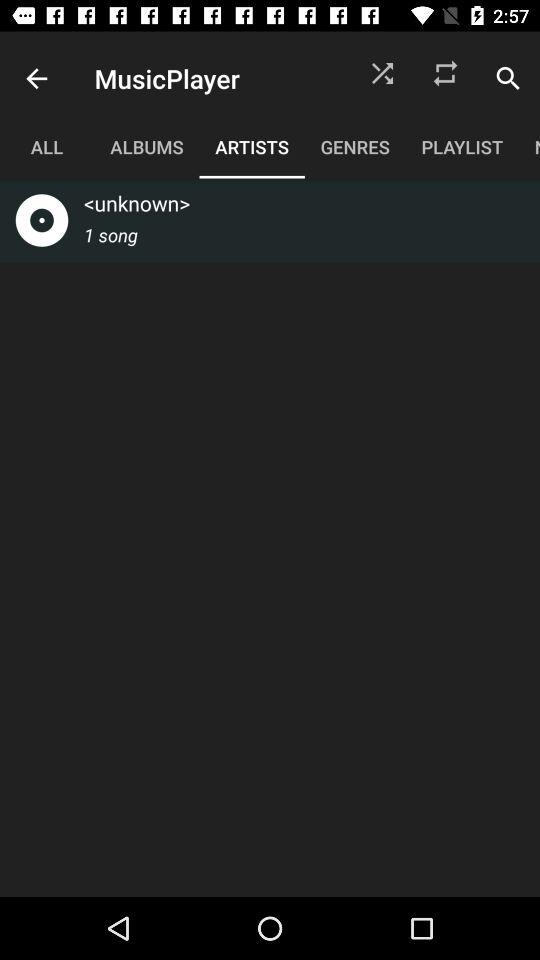What is the number of songs in the "unknown"? The number of songs is 1. 